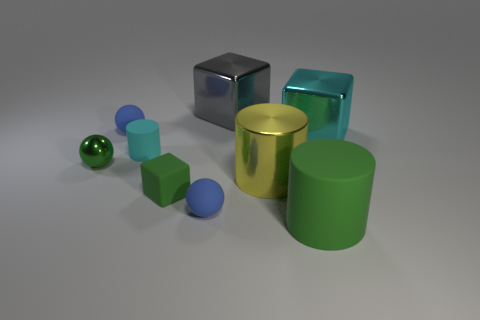Is there a large green cylinder made of the same material as the tiny cylinder?
Provide a succinct answer. Yes. What is the material of the cyan cube that is the same size as the yellow cylinder?
Keep it short and to the point. Metal. Is the number of blue matte spheres left of the cyan rubber cylinder less than the number of green metal things that are in front of the metal cylinder?
Keep it short and to the point. No. The green object that is both on the right side of the cyan matte thing and behind the big rubber cylinder has what shape?
Keep it short and to the point. Cube. What number of large cyan shiny things are the same shape as the large gray metallic thing?
Make the answer very short. 1. What size is the gray object that is made of the same material as the tiny green ball?
Offer a very short reply. Large. Is the number of cyan metallic blocks greater than the number of large red rubber things?
Ensure brevity in your answer.  Yes. The big metal object that is in front of the cyan block is what color?
Make the answer very short. Yellow. There is a metallic thing that is in front of the small cyan rubber cylinder and to the right of the small cyan rubber cylinder; what size is it?
Your response must be concise. Large. What number of other shiny cubes are the same size as the gray cube?
Provide a succinct answer. 1. 